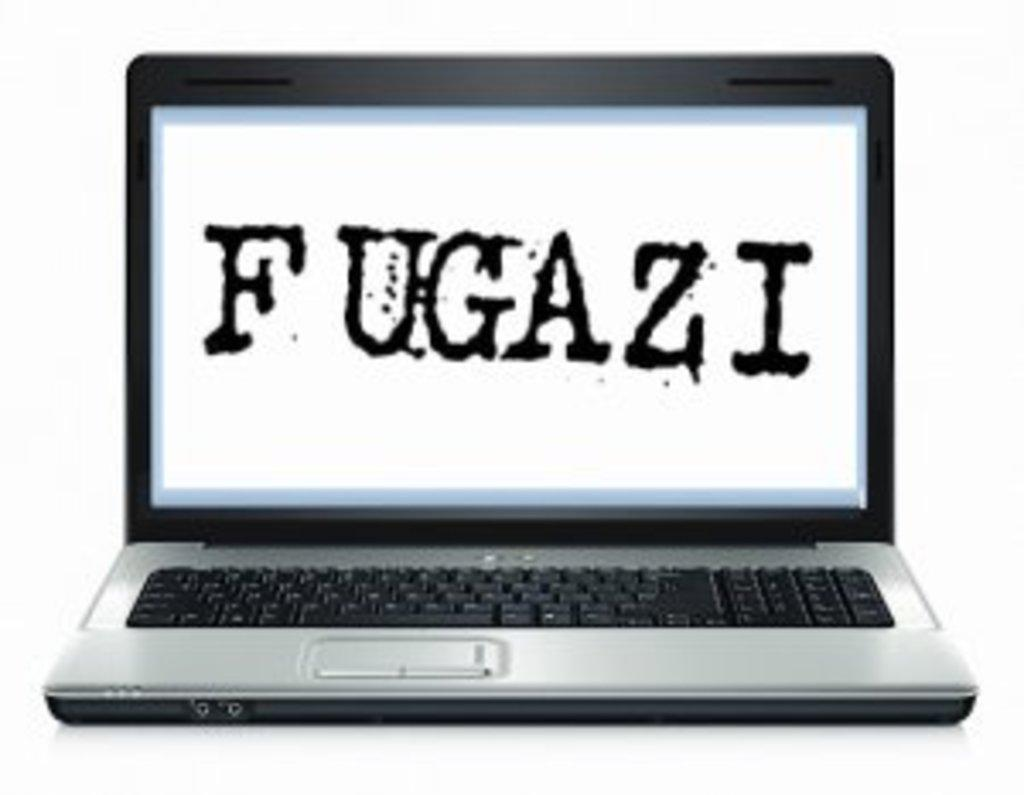What electronic device is visible in the image? There is a laptop in the image. What is the color of the surface on which the laptop is placed? The laptop is on a white surface. What can be seen on the laptop screen? Something is written on the laptop screen. Can you tell me how many robins are sitting on the laptop in the image? There are no robins present in the image; it features a laptop on a white surface with something written on the screen. 